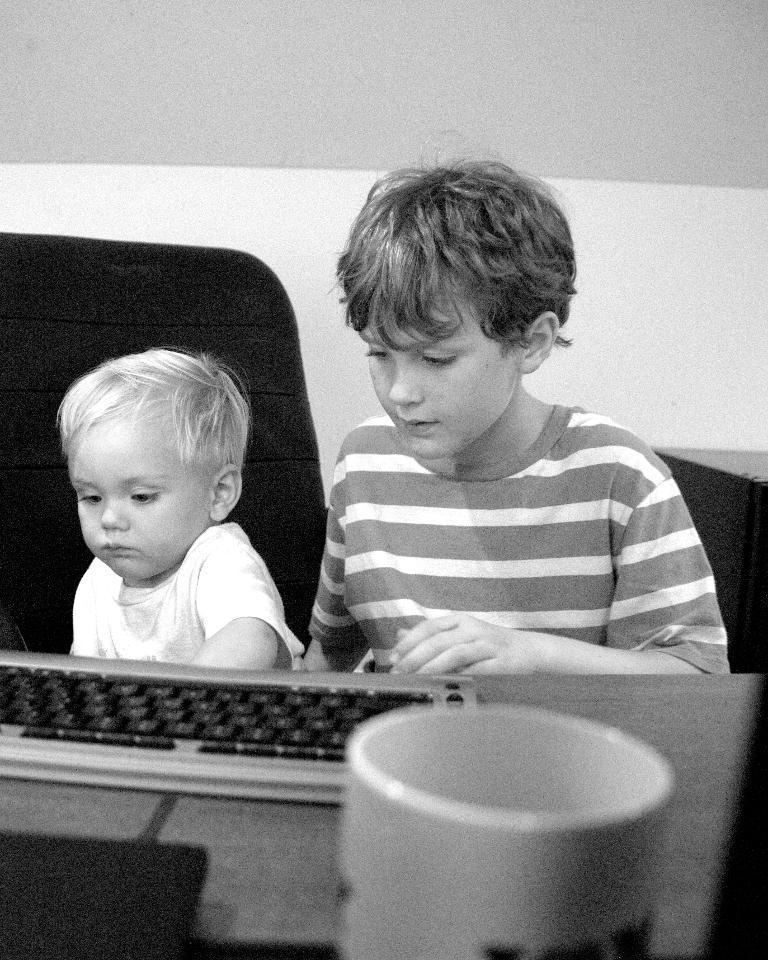In one or two sentences, can you explain what this image depicts? In this picture there is a boy sitting on the chair. There is also another boy. There is a keyboard , a cup on the table. 